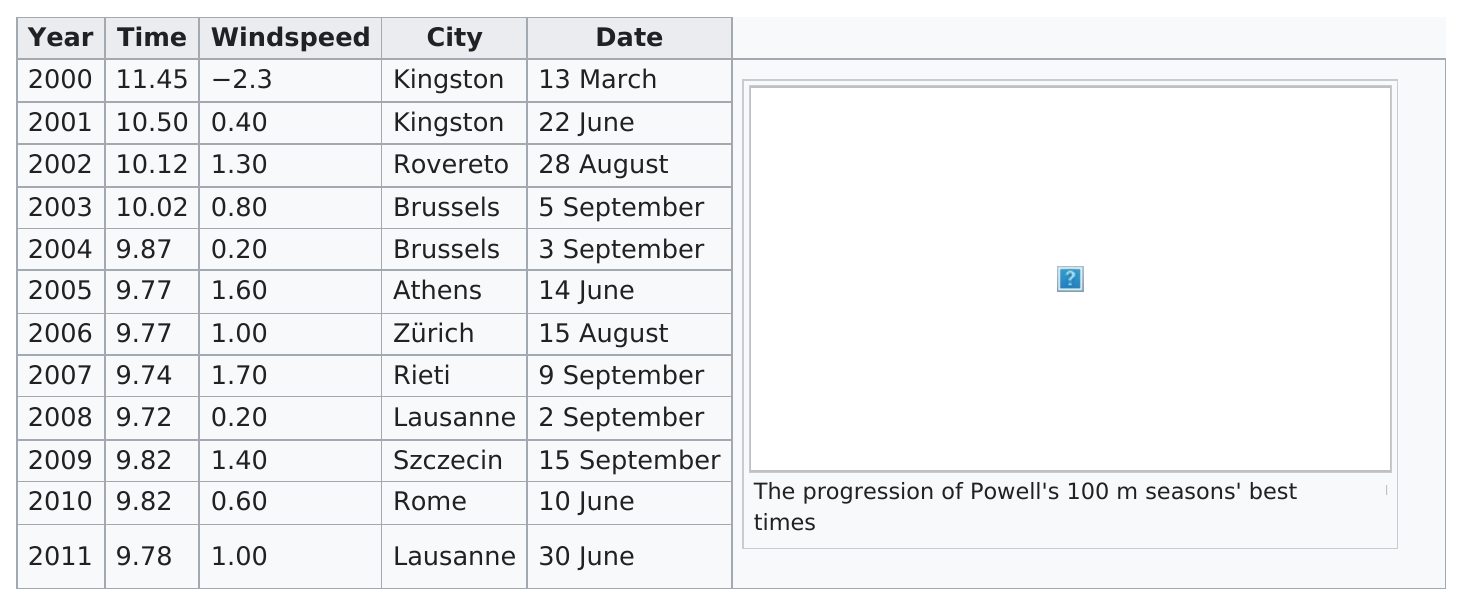Give some essential details in this illustration. The race was run under 10 seconds a total of 8 times. The first time the race was finished in under 10 seconds was in 2004. Lausanne is the city that is listed with the least amount of time. The difference between the first and last recorded times is 1.67... The average windspeed in Brussels was 0.50 meters per second. 